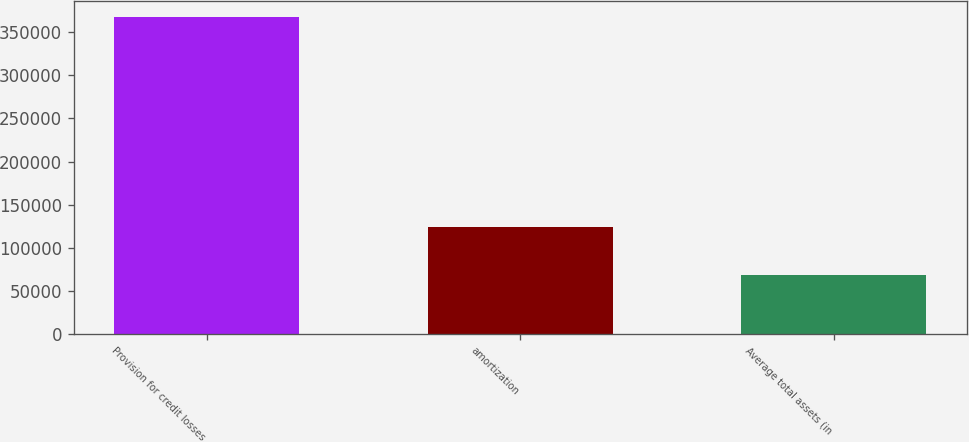Convert chart to OTSL. <chart><loc_0><loc_0><loc_500><loc_500><bar_chart><fcel>Provision for credit losses<fcel>amortization<fcel>Average total assets (in<nl><fcel>368000<fcel>124259<fcel>68380<nl></chart> 